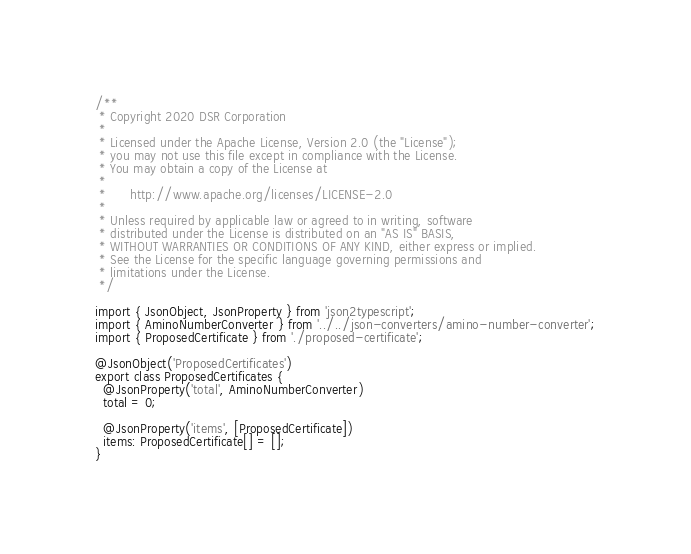<code> <loc_0><loc_0><loc_500><loc_500><_TypeScript_>/**
 * Copyright 2020 DSR Corporation
 *
 * Licensed under the Apache License, Version 2.0 (the "License");
 * you may not use this file except in compliance with the License.
 * You may obtain a copy of the License at
 *
 *      http://www.apache.org/licenses/LICENSE-2.0
 *
 * Unless required by applicable law or agreed to in writing, software
 * distributed under the License is distributed on an "AS IS" BASIS,
 * WITHOUT WARRANTIES OR CONDITIONS OF ANY KIND, either express or implied.
 * See the License for the specific language governing permissions and
 * limitations under the License.
 */

import { JsonObject, JsonProperty } from 'json2typescript';
import { AminoNumberConverter } from '../../json-converters/amino-number-converter';
import { ProposedCertificate } from './proposed-certificate';

@JsonObject('ProposedCertificates')
export class ProposedCertificates {
  @JsonProperty('total', AminoNumberConverter)
  total = 0;

  @JsonProperty('items', [ProposedCertificate])
  items: ProposedCertificate[] = [];
}
</code> 